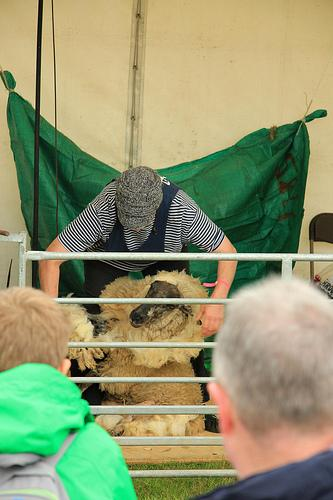Provide a short description of the key action in the photograph. A man sheers a sheep as spectators gather with a green tarp seen in the background. Please provide a brief description of the central activity happening in the picture. A man is sheering a sheep in the photo, with several people observing and a green tarp in the background. Explain what's going on in the picture in simple terms. A man is cutting a sheep's wool, while other people watch him do it, and there's a green cover nearby. Summarize the main components of this image in one sentence. The image features a man sheering a sheep, two people watching, and a green tarp behind them. What is the most noticeable happening in this photograph? In the photograph, a man is sheering a sheep with onlookers and a green tarp in the background. Briefly explain the main action in this photograph. A man sheers a sheep as a small group of people watch, with a green tarp in the background. Write a concise explanation of the primary focus in this image. The main focus of the image is a man sheering a sheep, while others observe the process. Elaborate on the focal point of the image. The image's focal point is a man sheering a sheep with observers nearby, and a green tarp in the background. Describe the main scene in the picture. A man is sheering a sheep, while a group of people watch, and there's a green tarp behind them. Mention the primary activity shown in the image. The main activity in the image is a man sheering a sheep in the presence of onlookers. 